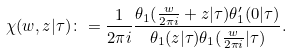<formula> <loc_0><loc_0><loc_500><loc_500>\chi ( w , z | \tau ) \colon = \frac { 1 } { 2 \pi i } \frac { \theta _ { 1 } ( \frac { w } { 2 \pi i } + z | \tau ) \theta ^ { \prime } _ { 1 } ( 0 | \tau ) } { \theta _ { 1 } ( z | \tau ) \theta _ { 1 } ( \frac { w } { 2 \pi i } | \tau ) } .</formula> 